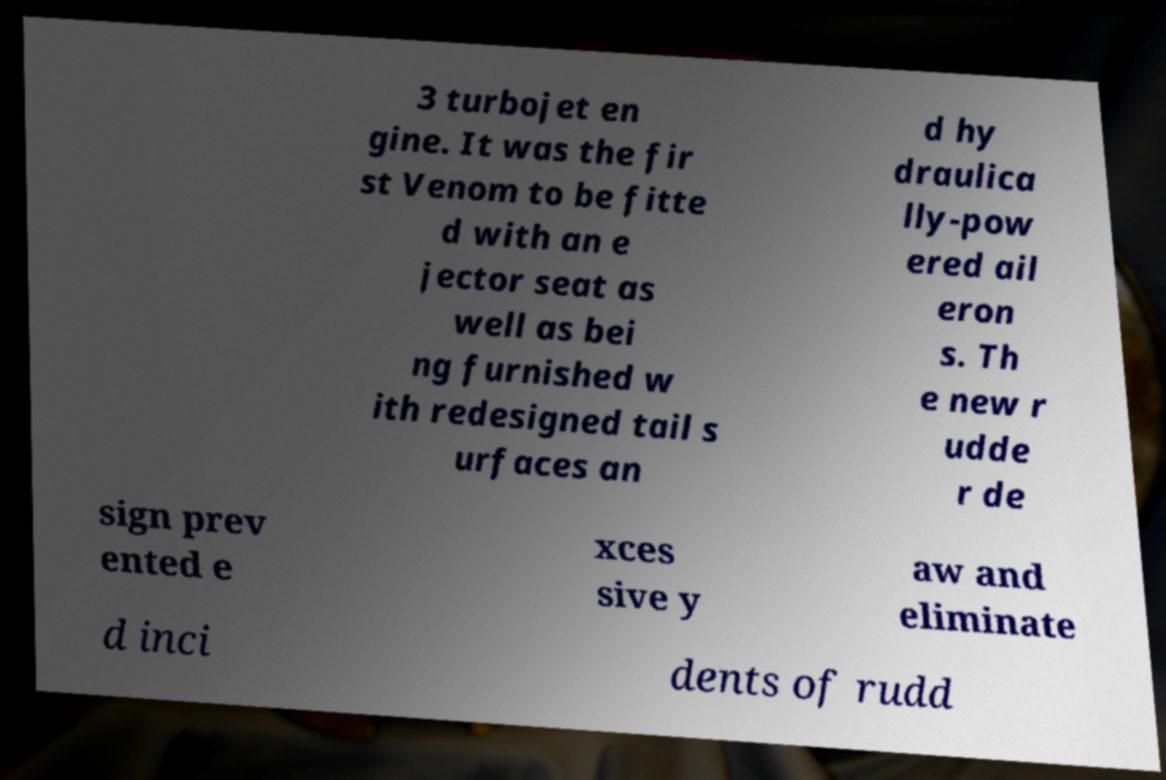Could you extract and type out the text from this image? 3 turbojet en gine. It was the fir st Venom to be fitte d with an e jector seat as well as bei ng furnished w ith redesigned tail s urfaces an d hy draulica lly-pow ered ail eron s. Th e new r udde r de sign prev ented e xces sive y aw and eliminate d inci dents of rudd 